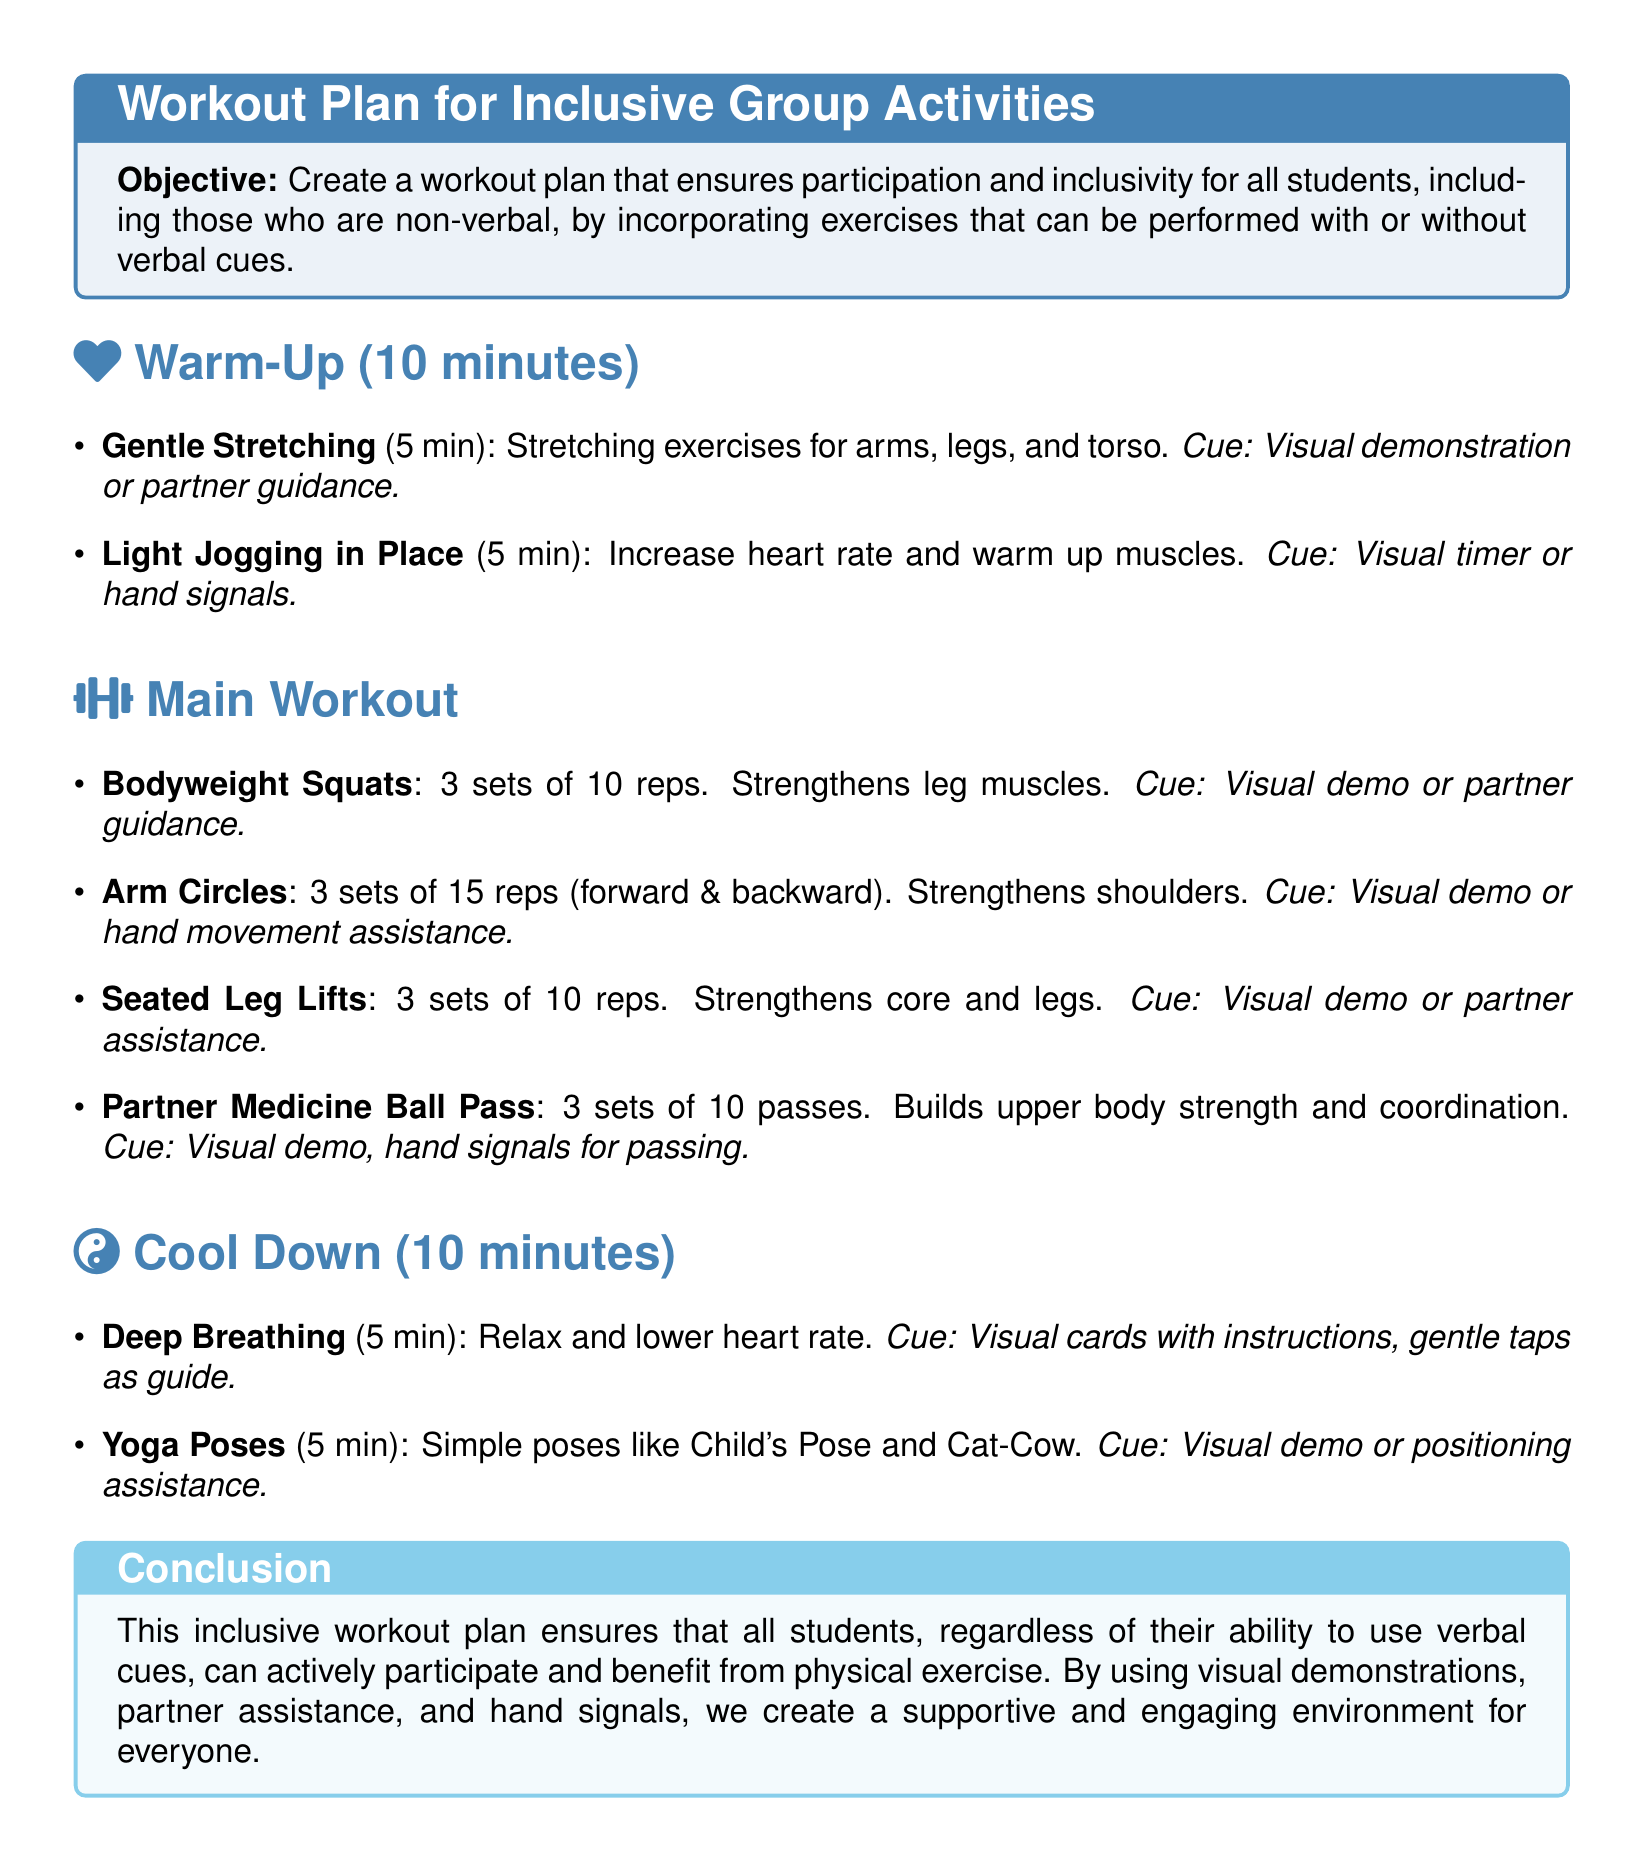What is the duration of the warm-up? The warm-up section specifies that its duration is 10 minutes.
Answer: 10 minutes How many sets of bodyweight squats are performed? The bodyweight squats exercise indicates that 3 sets are performed.
Answer: 3 sets What type of breathing exercise is included in the cool-down? The cool-down section mentions deep breathing as a relaxation exercise.
Answer: Deep breathing What kind of cues are used for yoga poses? The document states that visual demonstrations or positioning assistance are used as cues for yoga poses.
Answer: Visual demo or positioning assistance Which exercise involves a partner? The partner medicine ball pass is an exercise that specifically involves another participant.
Answer: Partner medicine ball pass What is the main objective of the workout plan? The objective clearly stated is to foster participation and inclusivity for all students.
Answer: Foster participation and inclusivity How long is the cool-down section? The document indicates that the cool-down section is also 10 minutes long.
Answer: 10 minutes What exercise strengthens core and legs? Seated leg lifts are listed as an exercise that strengthens both core and legs.
Answer: Seated leg lifts What kind of assistance is suggested for arm circles? The plan suggests using visual demos or hand movement assistance for arm circles.
Answer: Visual demo or hand movement assistance 